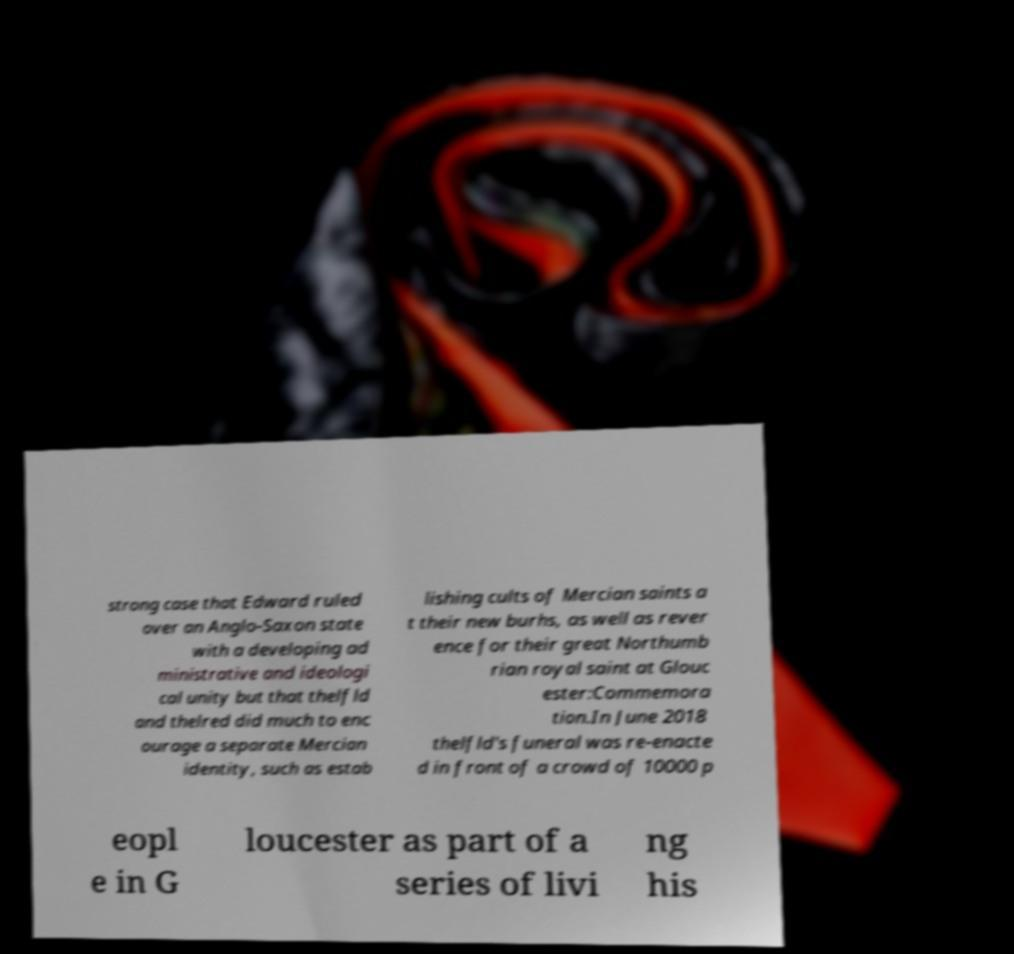What messages or text are displayed in this image? I need them in a readable, typed format. strong case that Edward ruled over an Anglo-Saxon state with a developing ad ministrative and ideologi cal unity but that thelfld and thelred did much to enc ourage a separate Mercian identity, such as estab lishing cults of Mercian saints a t their new burhs, as well as rever ence for their great Northumb rian royal saint at Glouc ester:Commemora tion.In June 2018 thelfld's funeral was re-enacte d in front of a crowd of 10000 p eopl e in G loucester as part of a series of livi ng his 